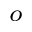<formula> <loc_0><loc_0><loc_500><loc_500>^ { o }</formula> 